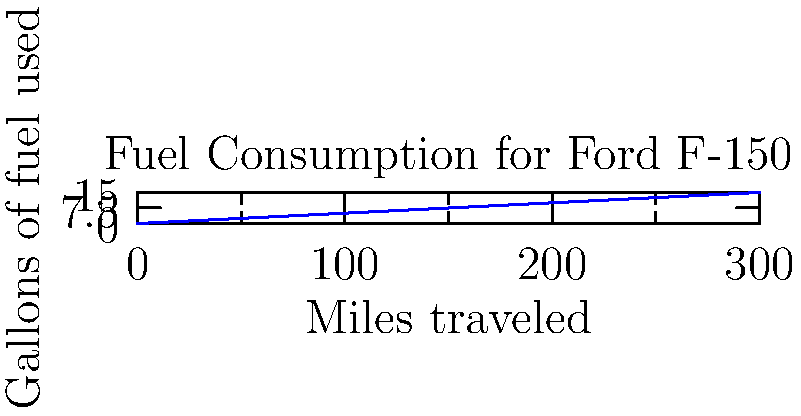Your trusty Ford F-150 pickup truck has been serving you well on your ranch. You decide to track its fuel efficiency during a long haul to transport cattle. Using the graph above, which shows the relationship between miles traveled and gallons of fuel used, calculate the fuel efficiency of your truck in miles per gallon (MPG). To calculate the fuel efficiency in miles per gallon (MPG), we need to determine how many miles the truck can travel per gallon of fuel.

Step 1: Identify two points on the graph to calculate the rate.
Let's use (0,0) and (300,15) for a more accurate result.

Step 2: Calculate the change in miles (distance traveled).
$\Delta \text{miles} = 300 - 0 = 300 \text{ miles}$

Step 3: Calculate the change in gallons (fuel consumed).
$\Delta \text{gallons} = 15 - 0 = 15 \text{ gallons}$

Step 4: Calculate MPG by dividing miles traveled by gallons consumed.
$\text{MPG} = \frac{\Delta \text{miles}}{\Delta \text{gallons}} = \frac{300 \text{ miles}}{15 \text{ gallons}} = 20 \text{ miles per gallon}$

Therefore, the fuel efficiency of your Ford F-150 is 20 MPG.
Answer: 20 MPG 